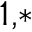Convert formula to latex. <formula><loc_0><loc_0><loc_500><loc_500>^ { 1 , * }</formula> 